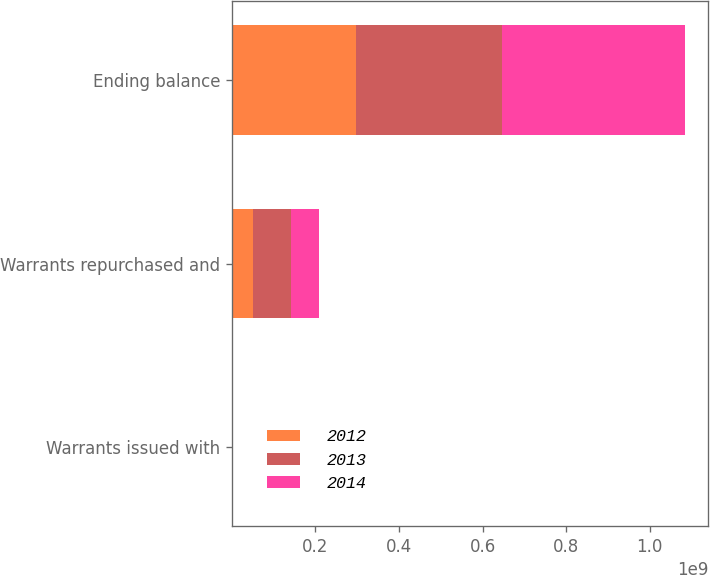<chart> <loc_0><loc_0><loc_500><loc_500><stacked_bar_chart><ecel><fcel>Warrants issued with<fcel>Warrants repurchased and<fcel>Ending balance<nl><fcel>2012<fcel>4315<fcel>4.97834e+07<fcel>2.98136e+08<nl><fcel>2013<fcel>118377<fcel>9.19736e+07<fcel>3.47933e+08<nl><fcel>2014<fcel>859796<fcel>6.56492e+07<fcel>4.39809e+08<nl></chart> 